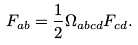Convert formula to latex. <formula><loc_0><loc_0><loc_500><loc_500>F _ { a b } = \frac { 1 } { 2 } \Omega _ { a b c d } F _ { c d } .</formula> 